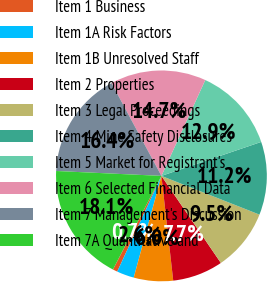<chart> <loc_0><loc_0><loc_500><loc_500><pie_chart><fcel>Item 1 Business<fcel>Item 1A Risk Factors<fcel>Item 1B Unresolved Staff<fcel>Item 2 Properties<fcel>Item 3 Legal Proceedings<fcel>Item 4 Mine Safety Disclosures<fcel>Item 5 Market for Registrant's<fcel>Item 6 Selected Financial Data<fcel>Item 7 Management's Discussion<fcel>Item 7A Quantitative and<nl><fcel>0.72%<fcel>2.65%<fcel>6.02%<fcel>7.75%<fcel>9.48%<fcel>11.21%<fcel>12.95%<fcel>14.68%<fcel>16.41%<fcel>18.14%<nl></chart> 